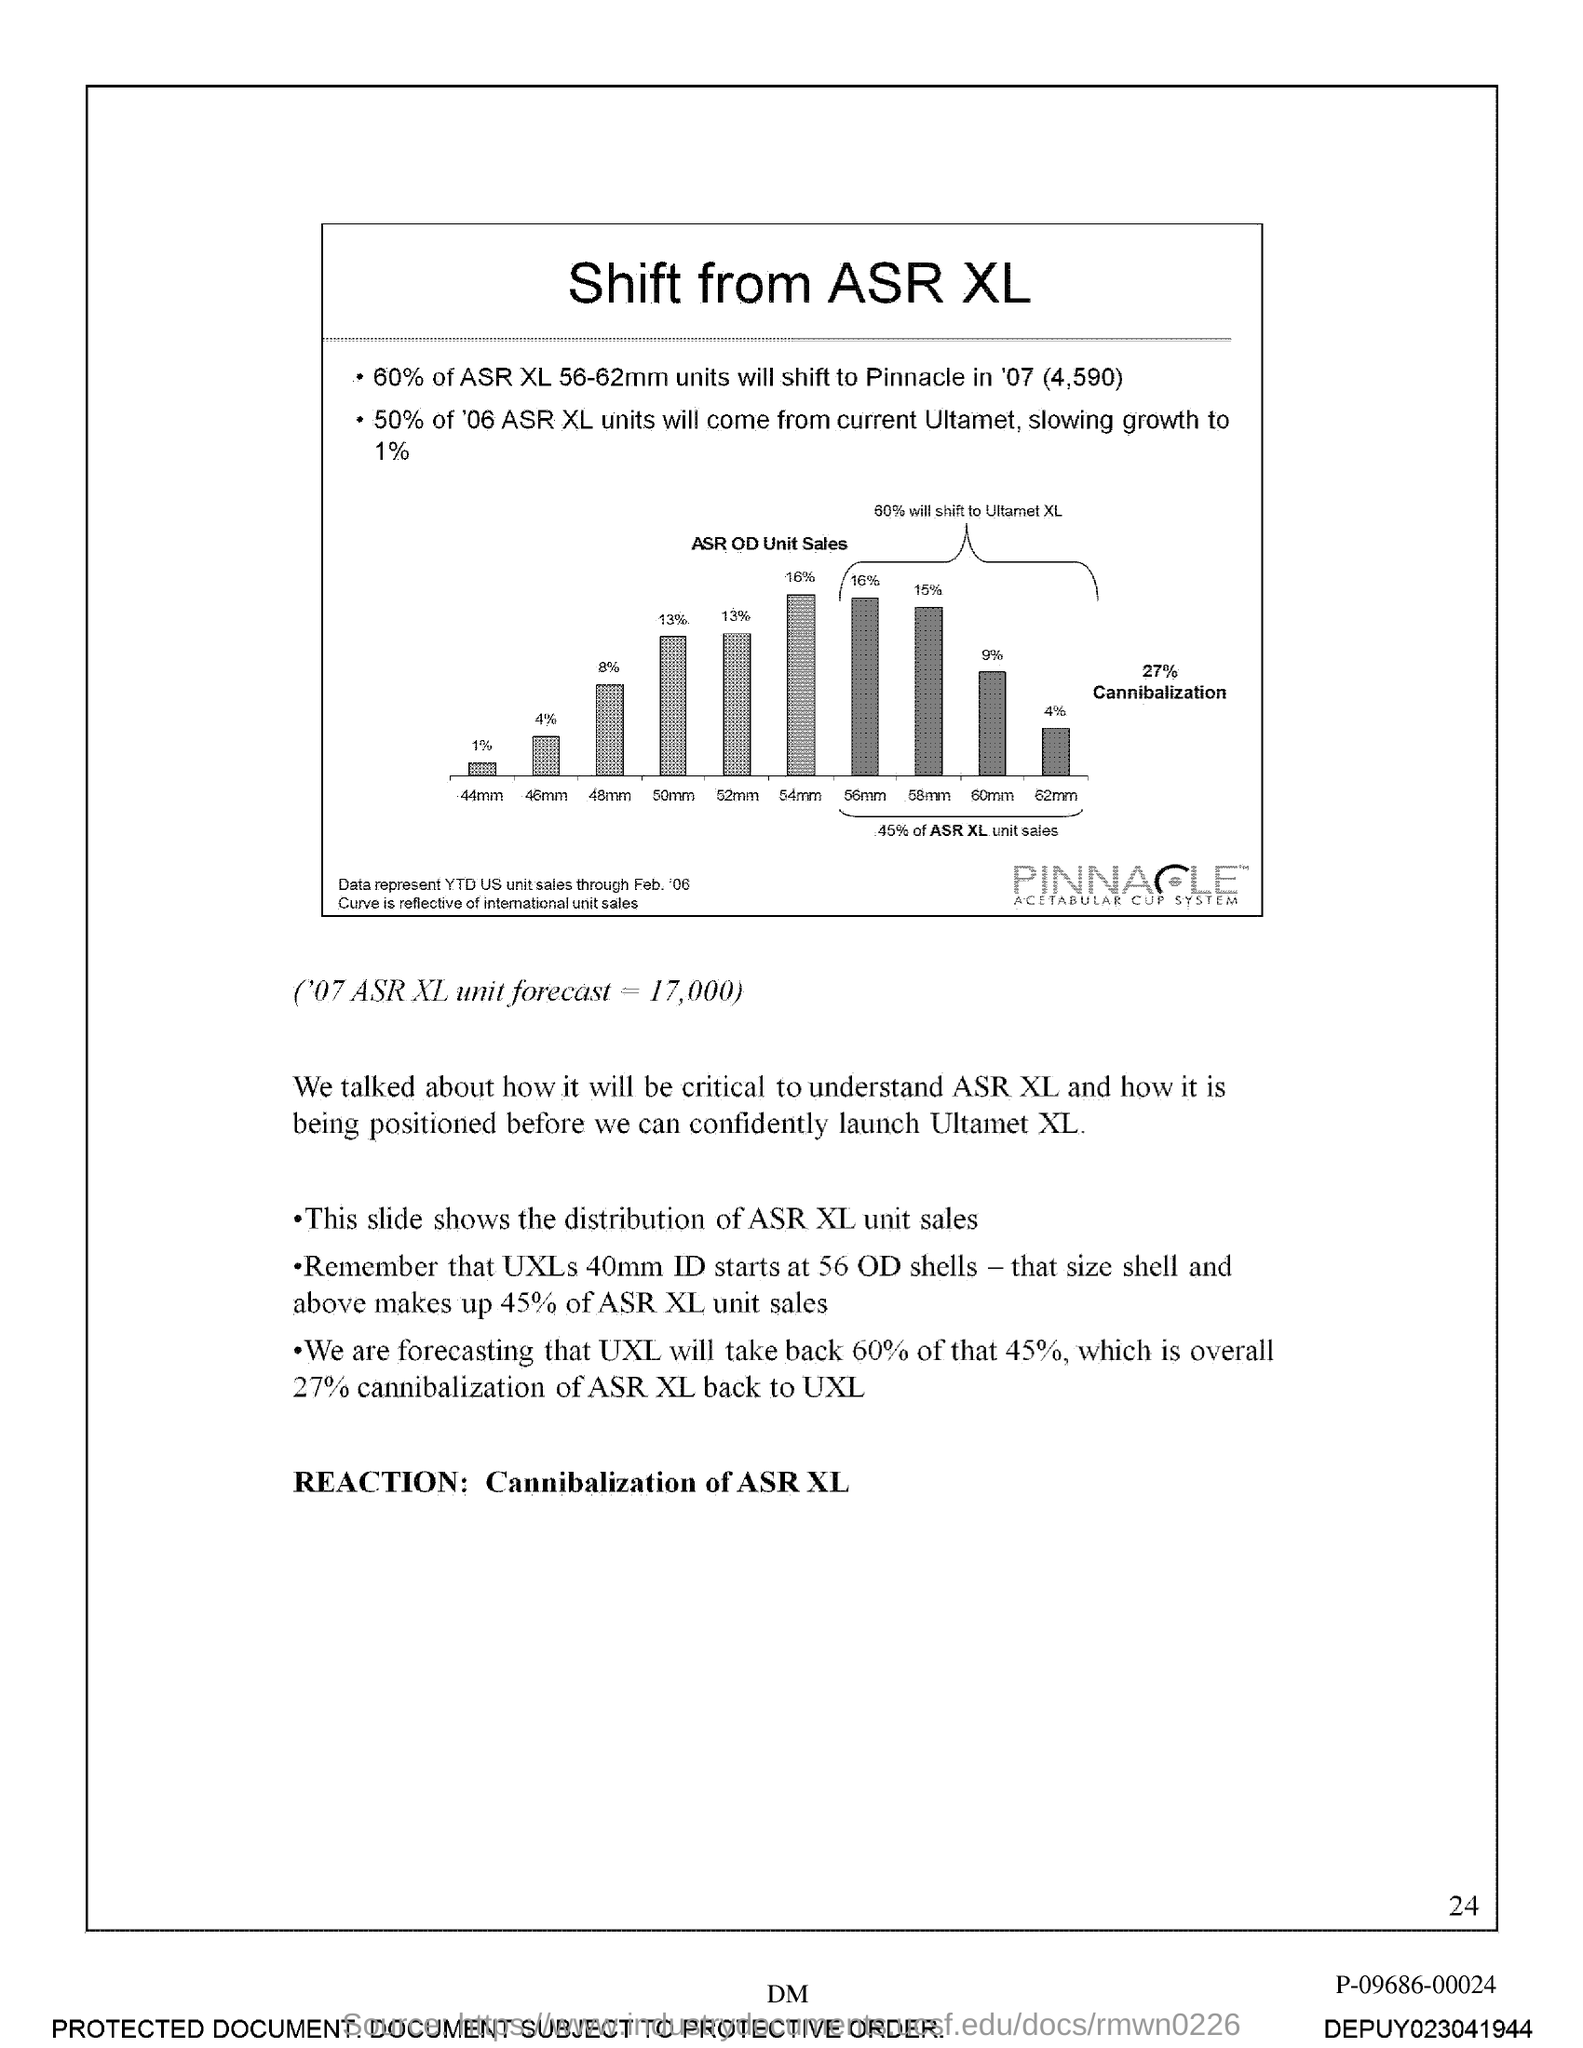What is the Page Number?
Your answer should be compact. 24. 